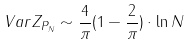Convert formula to latex. <formula><loc_0><loc_0><loc_500><loc_500>\ V a r Z _ { P _ { N } } \sim \frac { 4 } { \pi } ( 1 - \frac { 2 } { \pi } ) \cdot \ln { N }</formula> 